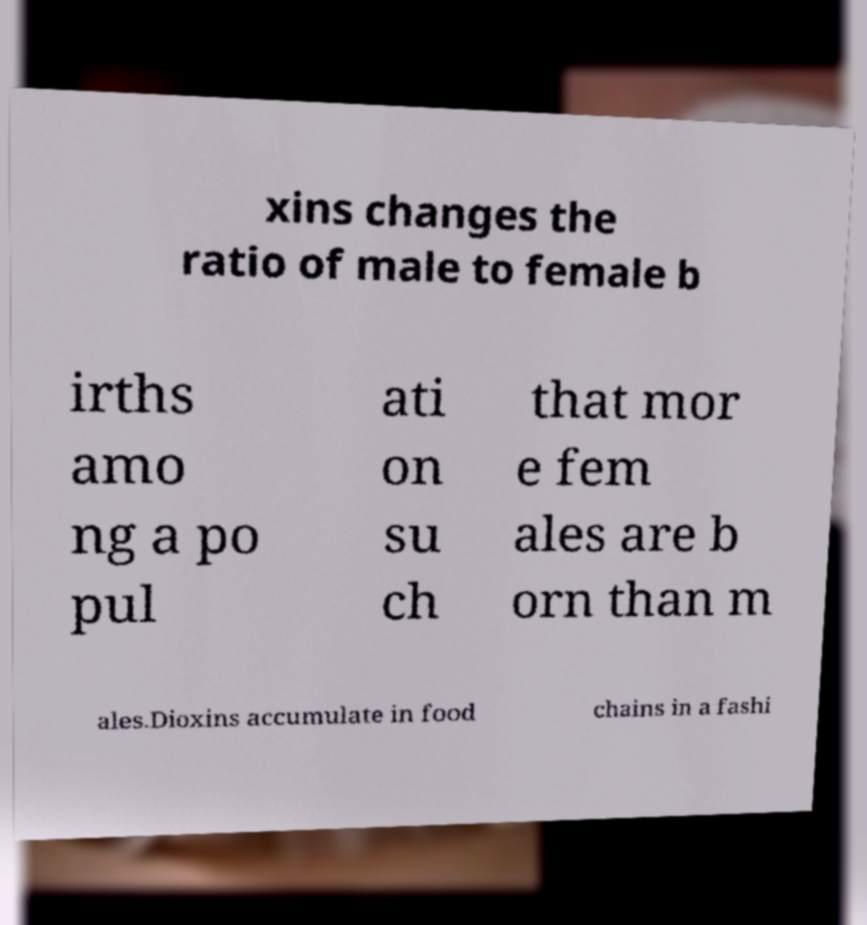There's text embedded in this image that I need extracted. Can you transcribe it verbatim? xins changes the ratio of male to female b irths amo ng a po pul ati on su ch that mor e fem ales are b orn than m ales.Dioxins accumulate in food chains in a fashi 